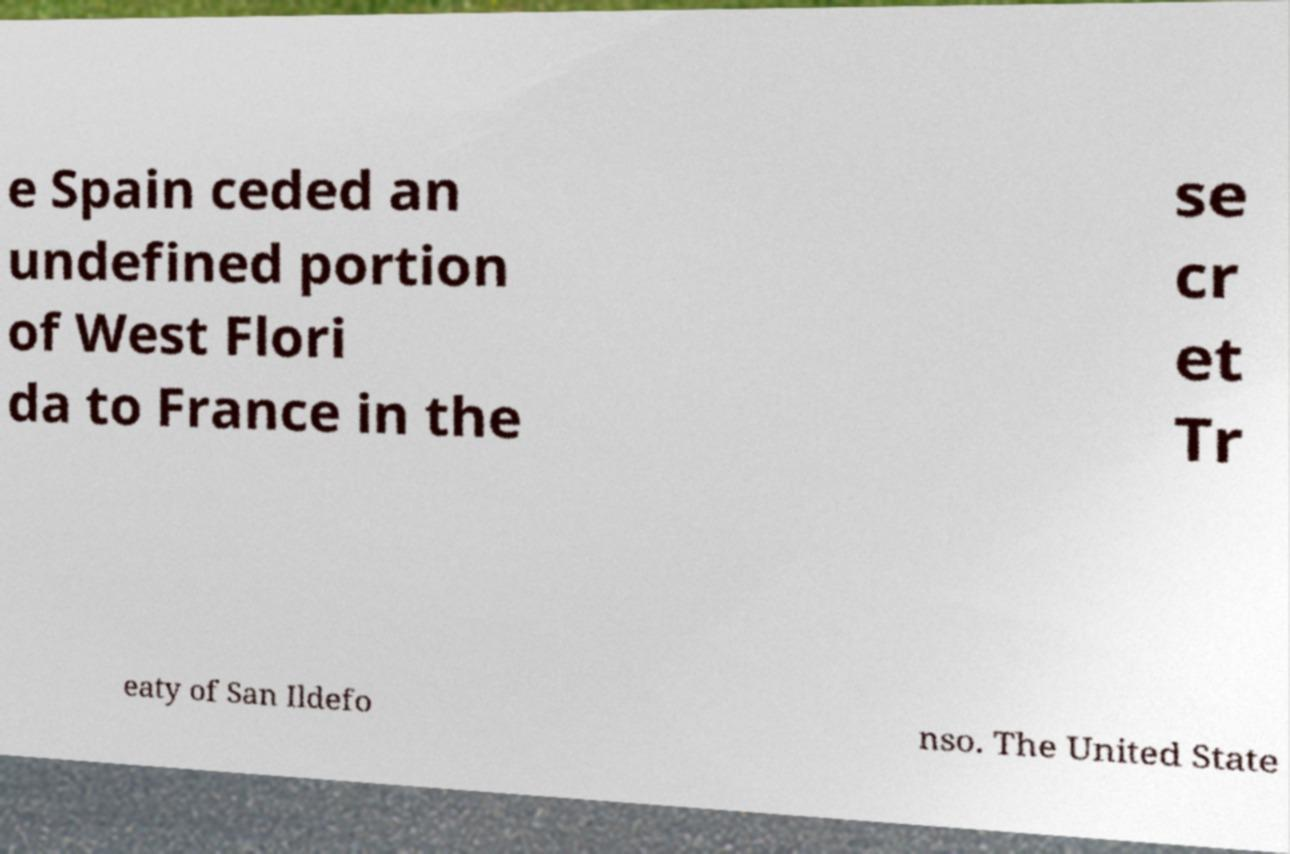Please read and relay the text visible in this image. What does it say? e Spain ceded an undefined portion of West Flori da to France in the se cr et Tr eaty of San Ildefo nso. The United State 